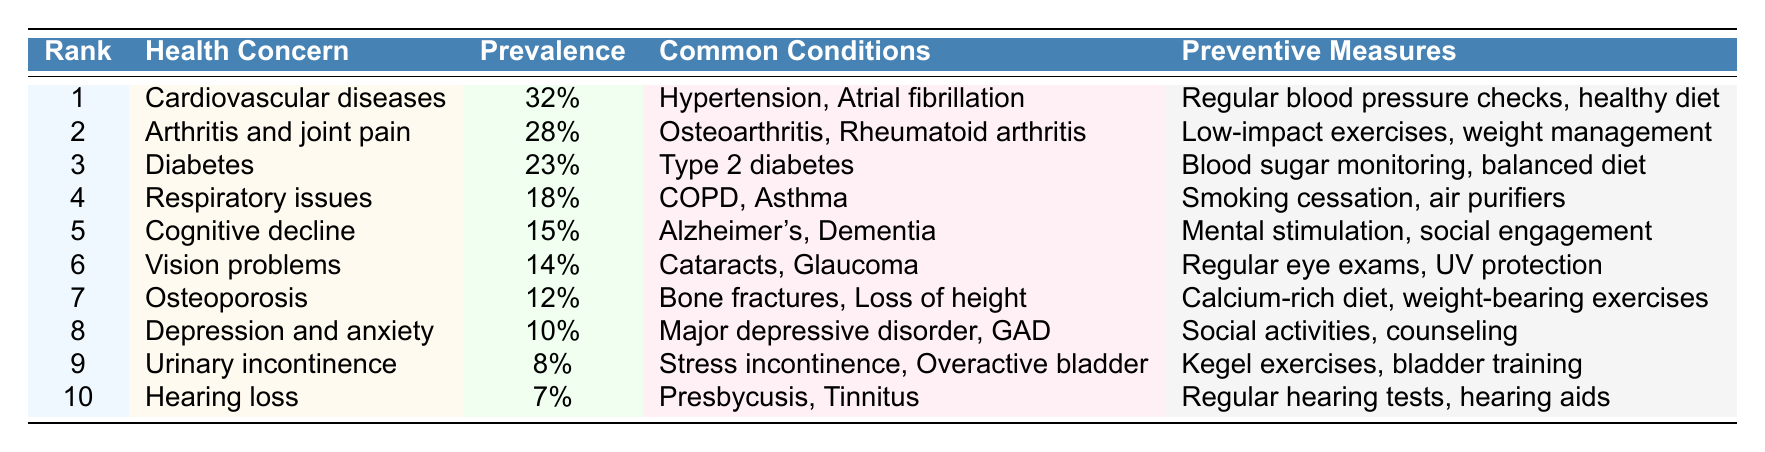What is the most frequent health concern among elderly expats in Spain? The table shows the rank of health concerns, and the highest rank is 1, which corresponds to "Cardiovascular diseases."
Answer: Cardiovascular diseases What is the prevalence of diabetes among elderly expats in Spain? According to the table, the prevalence of diabetes is specified as "23%."
Answer: 23% Which health concern has the lowest prevalence? By examining the table, "Hearing loss" is noted to have the lowest prevalence at "7%."
Answer: Hearing loss Name two common conditions associated with arthritis and joint pain. The table lists "Osteoarthritis" and "Rheumatoid arthritis" as common conditions for arthritis and joint pain.
Answer: Osteoarthritis, Rheumatoid arthritis What are the preventive measures for cognitive decline? The health concern of cognitive decline has preventive measures stated as "Mental stimulation" and "social engagement."
Answer: Mental stimulation, social engagement How many health concerns have a prevalence of 10% or higher? By counting the entries in the table, there are 8 health concerns (Cardiovascular diseases, Arthritis and joint pain, Diabetes, Respiratory issues, Cognitive decline, Vision problems, Osteoporosis, and Depression and anxiety) with a prevalence of 10% or above.
Answer: 8 Is the prevalence of urinary incontinence greater than that of hearing loss? The table indicates that urinary incontinence has a prevalence of "8%" while hearing loss has "7%," confirming that urinary incontinence is greater.
Answer: Yes What is the difference in prevalence between cardiovascular diseases and arthritis and joint pain? The prevalence of cardiovascular diseases is "32%" and arthritis and joint pain is "28%." The difference is calculated as 32% - 28% = 4%.
Answer: 4% Which preventive measures are recommended for respiratory issues? The preventive measures listed for respiratory issues include "Smoking cessation" and "air purifiers," as shown in the table.
Answer: Smoking cessation, air purifiers What percentage of elderly expats experience cognitive decline compared to diabetes? Cognitive decline has a prevalence of "15%" and diabetes "23%." To find out how much less cognitive decline is, we subtract: 23% - 15% = 8%.
Answer: 8% less 